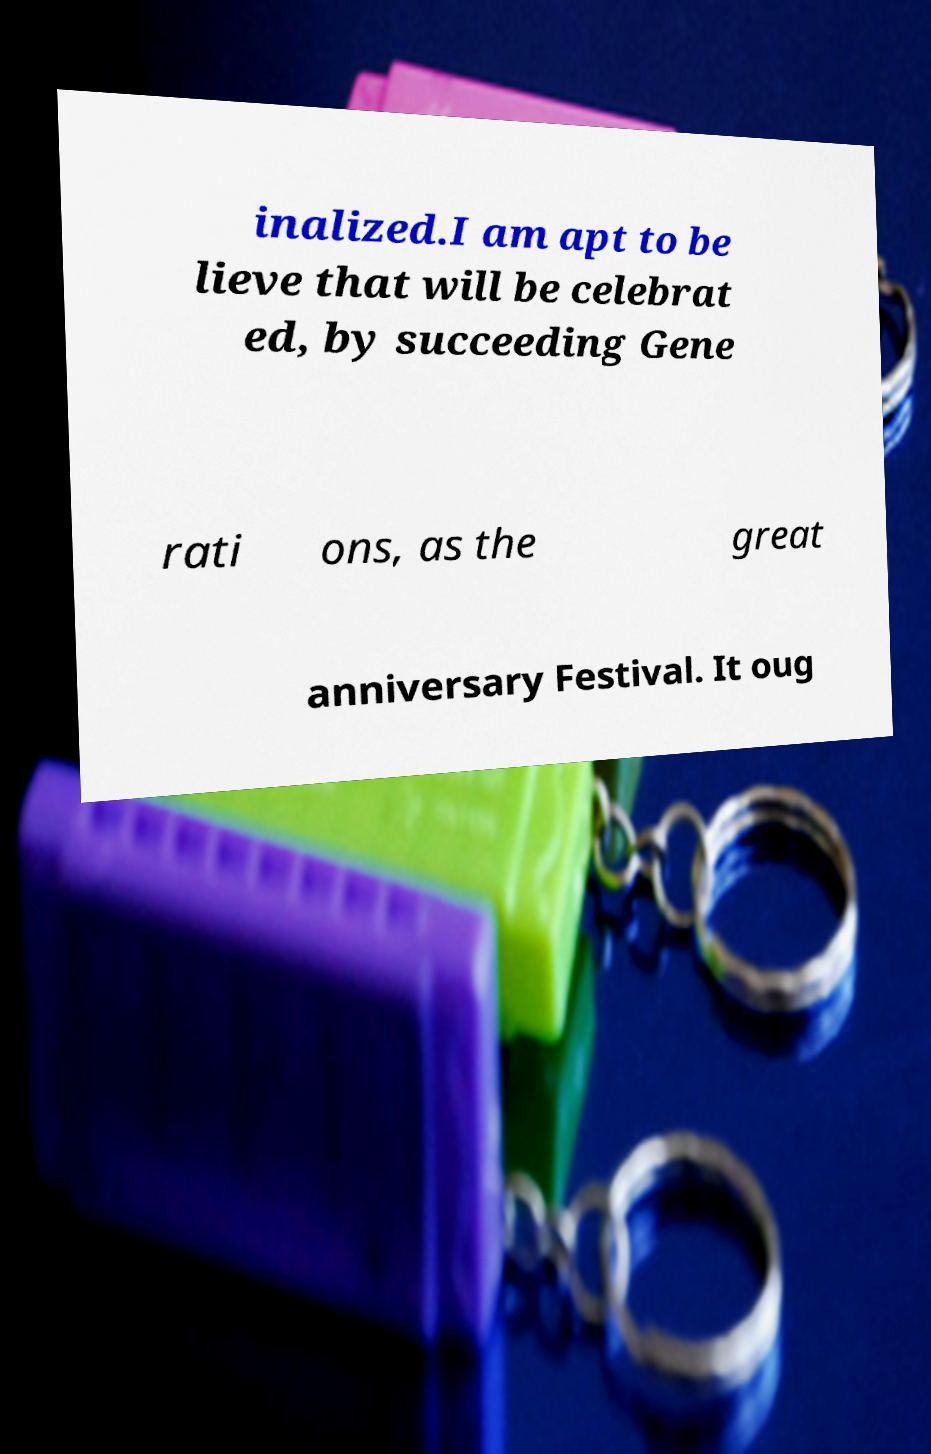Can you accurately transcribe the text from the provided image for me? inalized.I am apt to be lieve that will be celebrat ed, by succeeding Gene rati ons, as the great anniversary Festival. It oug 